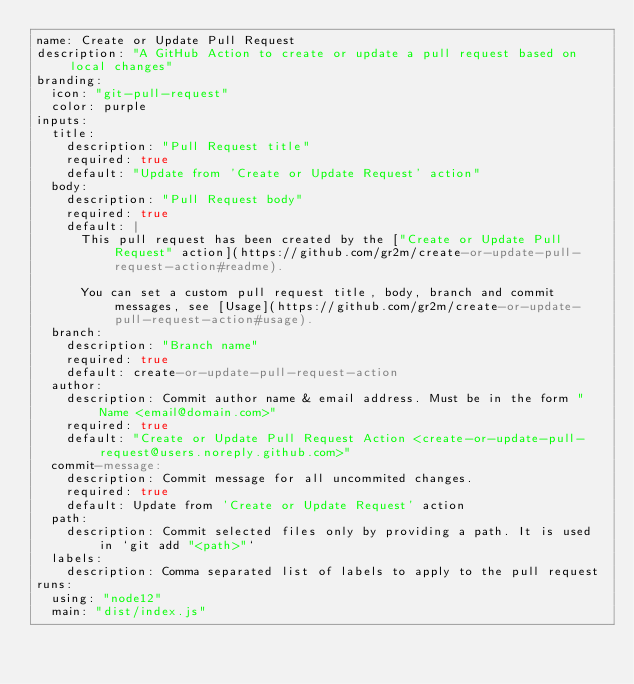<code> <loc_0><loc_0><loc_500><loc_500><_YAML_>name: Create or Update Pull Request
description: "A GitHub Action to create or update a pull request based on local changes"
branding:
  icon: "git-pull-request"
  color: purple
inputs:
  title:
    description: "Pull Request title"
    required: true
    default: "Update from 'Create or Update Request' action"
  body:
    description: "Pull Request body"
    required: true
    default: |
      This pull request has been created by the ["Create or Update Pull Request" action](https://github.com/gr2m/create-or-update-pull-request-action#readme). 

      You can set a custom pull request title, body, branch and commit messages, see [Usage](https://github.com/gr2m/create-or-update-pull-request-action#usage).
  branch:
    description: "Branch name"
    required: true
    default: create-or-update-pull-request-action
  author:
    description: Commit author name & email address. Must be in the form "Name <email@domain.com>"
    required: true
    default: "Create or Update Pull Request Action <create-or-update-pull-request@users.noreply.github.com>"
  commit-message:
    description: Commit message for all uncommited changes.
    required: true
    default: Update from 'Create or Update Request' action
  path:
    description: Commit selected files only by providing a path. It is used in `git add "<path>"`
  labels:
    description: Comma separated list of labels to apply to the pull request
runs:
  using: "node12"
  main: "dist/index.js"
</code> 